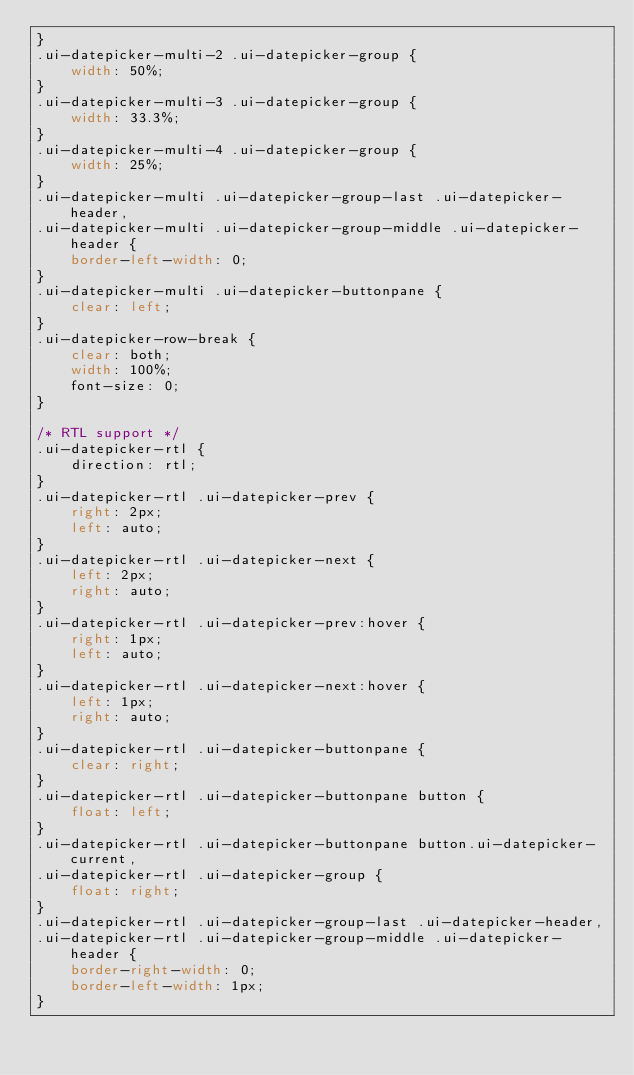<code> <loc_0><loc_0><loc_500><loc_500><_CSS_>}
.ui-datepicker-multi-2 .ui-datepicker-group {
	width: 50%;
}
.ui-datepicker-multi-3 .ui-datepicker-group {
	width: 33.3%;
}
.ui-datepicker-multi-4 .ui-datepicker-group {
	width: 25%;
}
.ui-datepicker-multi .ui-datepicker-group-last .ui-datepicker-header,
.ui-datepicker-multi .ui-datepicker-group-middle .ui-datepicker-header {
	border-left-width: 0;
}
.ui-datepicker-multi .ui-datepicker-buttonpane {
	clear: left;
}
.ui-datepicker-row-break {
	clear: both;
	width: 100%;
	font-size: 0;
}

/* RTL support */
.ui-datepicker-rtl {
	direction: rtl;
}
.ui-datepicker-rtl .ui-datepicker-prev {
	right: 2px;
	left: auto;
}
.ui-datepicker-rtl .ui-datepicker-next {
	left: 2px;
	right: auto;
}
.ui-datepicker-rtl .ui-datepicker-prev:hover {
	right: 1px;
	left: auto;
}
.ui-datepicker-rtl .ui-datepicker-next:hover {
	left: 1px;
	right: auto;
}
.ui-datepicker-rtl .ui-datepicker-buttonpane {
	clear: right;
}
.ui-datepicker-rtl .ui-datepicker-buttonpane button {
	float: left;
}
.ui-datepicker-rtl .ui-datepicker-buttonpane button.ui-datepicker-current,
.ui-datepicker-rtl .ui-datepicker-group {
	float: right;
}
.ui-datepicker-rtl .ui-datepicker-group-last .ui-datepicker-header,
.ui-datepicker-rtl .ui-datepicker-group-middle .ui-datepicker-header {
	border-right-width: 0;
	border-left-width: 1px;
}
</code> 